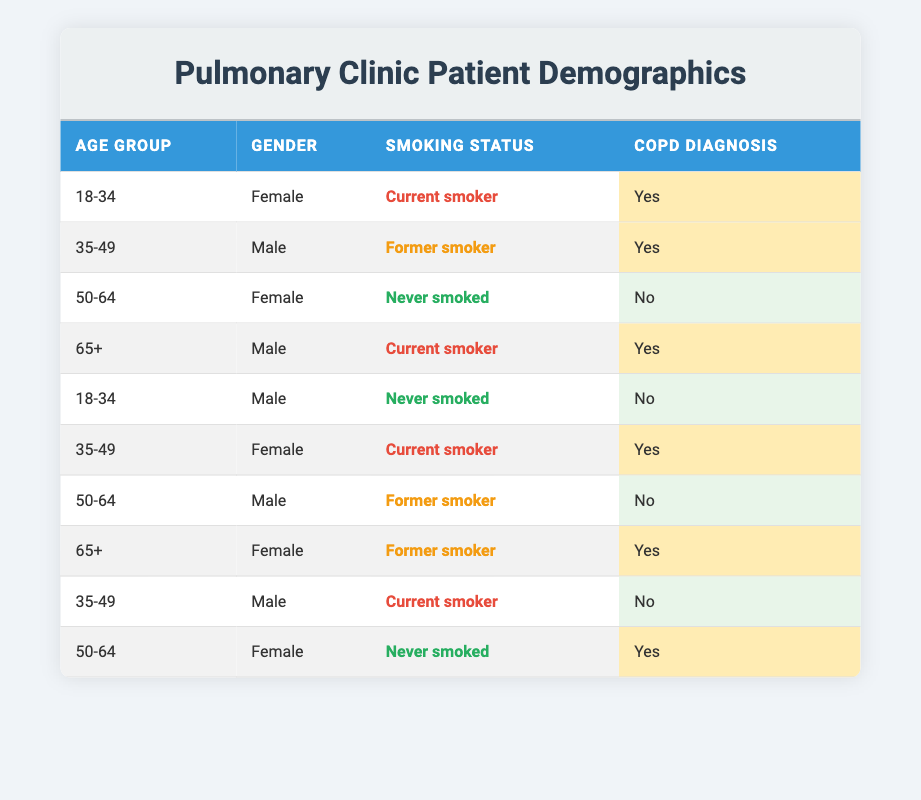What is the smoking status of the female patient aged 18-34? There is only one female patient in the 18-34 age group, and her smoking status is listed as "Current smoker."
Answer: Current smoker How many patients in the 35-49 age group have a COPD diagnosis? In the table, there are three patients aged 35-49: one female who is a current smoker and has a COPD diagnosis, and two males, one a former smoker with a COPD diagnosis and one a current smoker without a COPD diagnosis. Thus, 2 out of 3 have a COPD diagnosis.
Answer: 2 What is the smoking status of patients in the 50-64 age group? There are three patients in the 50-64 age group: one female who never smoked (COPD diagnosis: Yes), one male who is a former smoker (COPD diagnosis: No), and another female who never smoked (COPD diagnosis: Yes). Therefore, the smoking statuses are "Never smoked" and "Former smoker."
Answer: Never smoked, Former smoker Are there any current smokers in the 65+ age group? Yes, there are two patients in the 65+ age group: one male is a current smoker (with COPD) and one female is a former smoker (with COPD). The question was about current smokers, and since one male is listed as a current smoker, the answer is yes.
Answer: Yes What is the total number of patients classified as "Former smoker"? In the table, four patients are classified as "Former smoker": one in the 35-49 age group (male), one in the 50-64 age group (male), one in the 65+ age group (female), and one in the 65+ age group (female). Adding them up gives a total of four former smokers.
Answer: 4 How many female patients have a COPD diagnosis? The table shows four female patients: one aged 18-34 (COPD: Yes), one aged 50-64 (COPD: No), another female aged 35-49 (COPD: Yes), and one in the 50-64 age group (COPD: Yes). Out of these, three female patients have a COPD diagnosis.
Answer: 3 What percentage of current smokers are diagnosed with COPD? The table lists six current smokers: one female aged 18-34 (COPD: Yes), one male aged 35-49 (COPD: No), one female aged 35-49 (COPD: Yes), and one male aged 65+ (COPD: Yes). Out of these, three have COPD. Therefore, the percentage of current smokers diagnosed with COPD is (3 out of 4 current smokers) * 100 = 75%.
Answer: 75% Is it true that all patients who never smoked have a COPD diagnosis? Reviewing the table, there are three patients listed as "Never smoked." Out of those, one has a COPD diagnosis (female aged 50-64). Thus, not all patients who never smoked have a COPD diagnosis, making the statement false.
Answer: False How many males have never smoked and do not have a COPD diagnosis? There are two males who have never smoked: one in the 18-34 age group (COPD: No) and one in the 50-64 age group (COPD: No). Both do not have a COPD diagnosis, totaling two males.
Answer: 2 